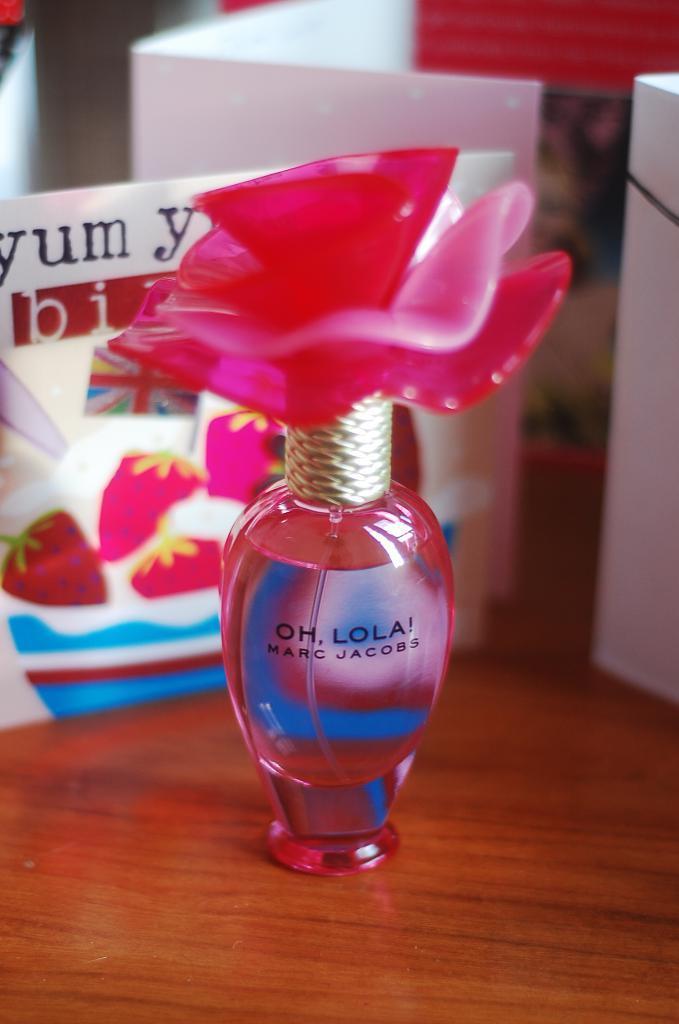<image>
Render a clear and concise summary of the photo. A pink bottle of Oh, Lola! Marc Jacobs perfume with a rose on top. 